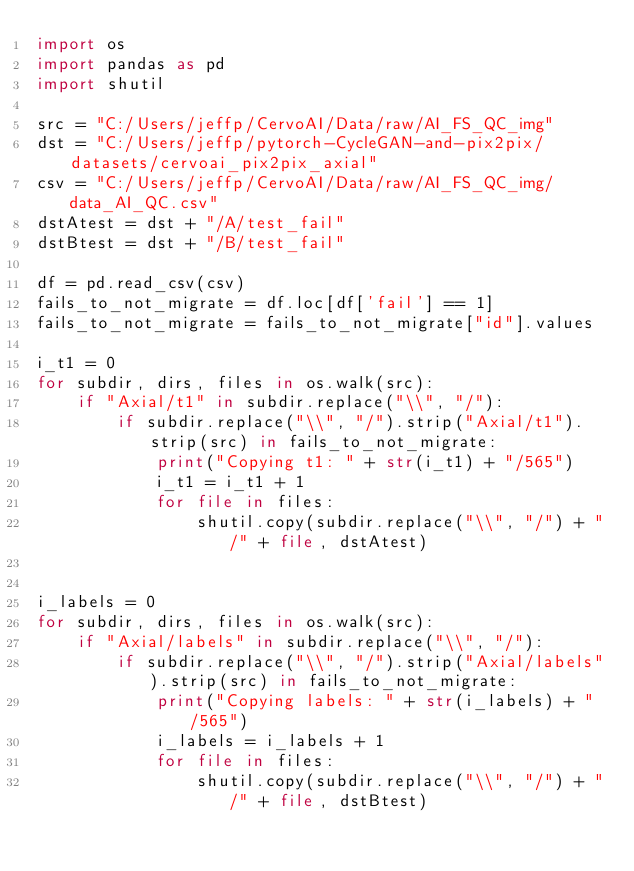<code> <loc_0><loc_0><loc_500><loc_500><_Python_>import os
import pandas as pd
import shutil

src = "C:/Users/jeffp/CervoAI/Data/raw/AI_FS_QC_img"
dst = "C:/Users/jeffp/pytorch-CycleGAN-and-pix2pix/datasets/cervoai_pix2pix_axial"
csv = "C:/Users/jeffp/CervoAI/Data/raw/AI_FS_QC_img/data_AI_QC.csv"
dstAtest = dst + "/A/test_fail"
dstBtest = dst + "/B/test_fail"

df = pd.read_csv(csv)
fails_to_not_migrate = df.loc[df['fail'] == 1]
fails_to_not_migrate = fails_to_not_migrate["id"].values

i_t1 = 0
for subdir, dirs, files in os.walk(src):
    if "Axial/t1" in subdir.replace("\\", "/"):
        if subdir.replace("\\", "/").strip("Axial/t1").strip(src) in fails_to_not_migrate:
            print("Copying t1: " + str(i_t1) + "/565")
            i_t1 = i_t1 + 1
            for file in files:
                shutil.copy(subdir.replace("\\", "/") + "/" + file, dstAtest)


i_labels = 0
for subdir, dirs, files in os.walk(src):
    if "Axial/labels" in subdir.replace("\\", "/"):
        if subdir.replace("\\", "/").strip("Axial/labels").strip(src) in fails_to_not_migrate:
            print("Copying labels: " + str(i_labels) + "/565")
            i_labels = i_labels + 1
            for file in files:
                shutil.copy(subdir.replace("\\", "/") + "/" + file, dstBtest)
</code> 